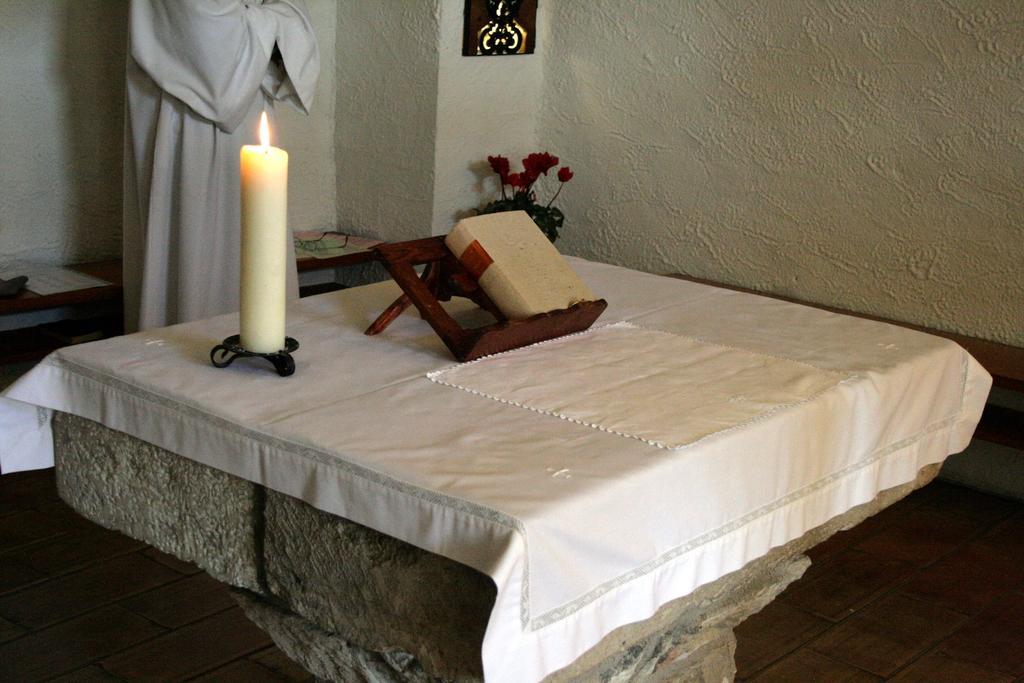How would you summarize this image in a sentence or two? We can see candle, book, stand and objects on the table. We can see idol. In the background we can see wall, flowers and objects on the table. 